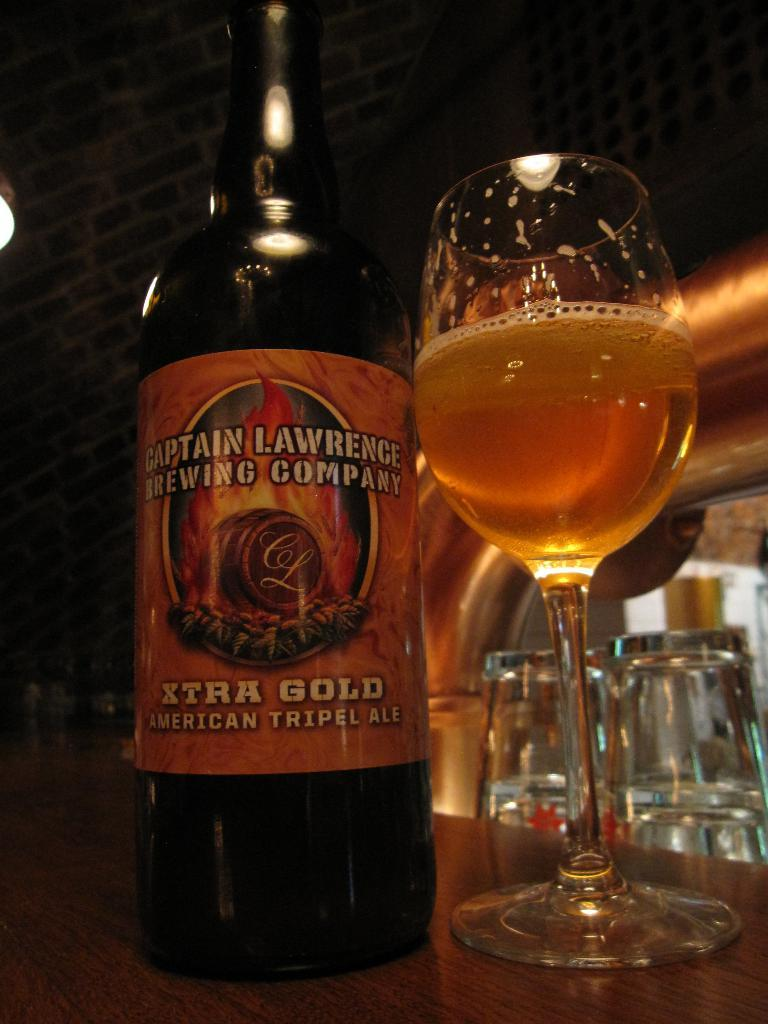Provide a one-sentence caption for the provided image. a bottle of alcohol labeled: Captain Lawrence brewing company. 